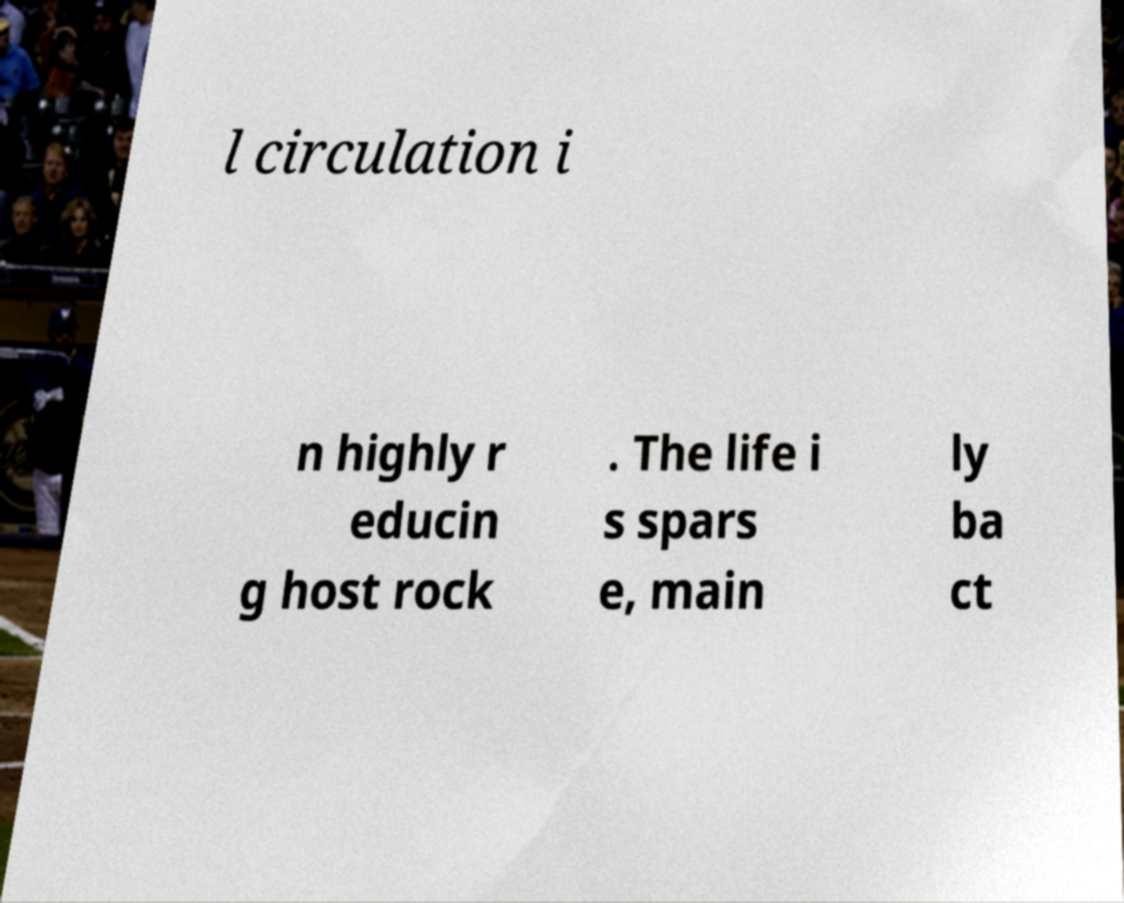Please read and relay the text visible in this image. What does it say? l circulation i n highly r educin g host rock . The life i s spars e, main ly ba ct 